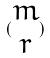<formula> <loc_0><loc_0><loc_500><loc_500>( \begin{matrix} m \\ r \end{matrix} )</formula> 